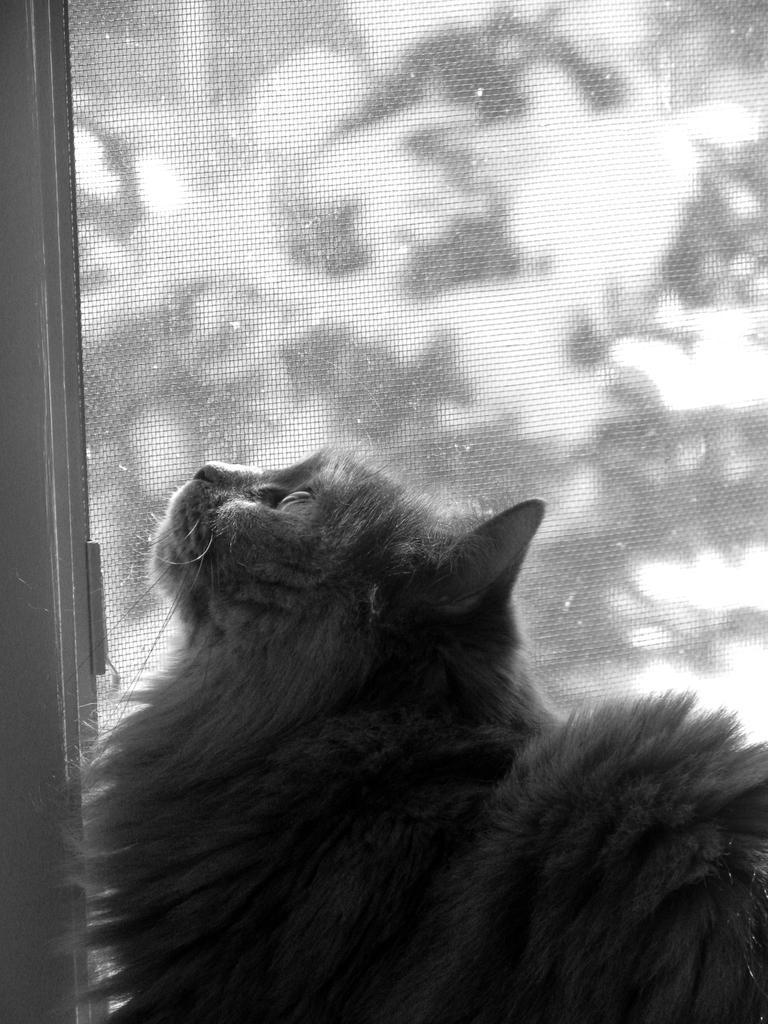In one or two sentences, can you explain what this image depicts? This is a black and white picture, in this image we can see an animal and in the background, it looks like a door. 